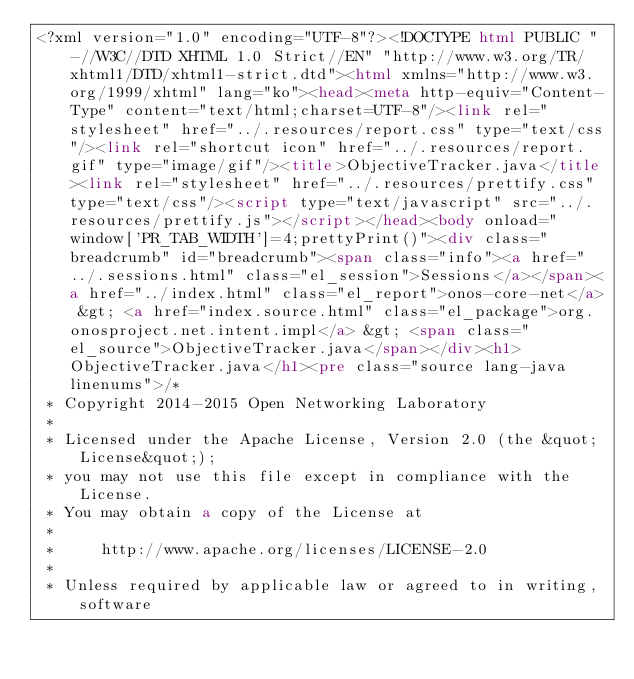<code> <loc_0><loc_0><loc_500><loc_500><_HTML_><?xml version="1.0" encoding="UTF-8"?><!DOCTYPE html PUBLIC "-//W3C//DTD XHTML 1.0 Strict//EN" "http://www.w3.org/TR/xhtml1/DTD/xhtml1-strict.dtd"><html xmlns="http://www.w3.org/1999/xhtml" lang="ko"><head><meta http-equiv="Content-Type" content="text/html;charset=UTF-8"/><link rel="stylesheet" href="../.resources/report.css" type="text/css"/><link rel="shortcut icon" href="../.resources/report.gif" type="image/gif"/><title>ObjectiveTracker.java</title><link rel="stylesheet" href="../.resources/prettify.css" type="text/css"/><script type="text/javascript" src="../.resources/prettify.js"></script></head><body onload="window['PR_TAB_WIDTH']=4;prettyPrint()"><div class="breadcrumb" id="breadcrumb"><span class="info"><a href="../.sessions.html" class="el_session">Sessions</a></span><a href="../index.html" class="el_report">onos-core-net</a> &gt; <a href="index.source.html" class="el_package">org.onosproject.net.intent.impl</a> &gt; <span class="el_source">ObjectiveTracker.java</span></div><h1>ObjectiveTracker.java</h1><pre class="source lang-java linenums">/*
 * Copyright 2014-2015 Open Networking Laboratory
 *
 * Licensed under the Apache License, Version 2.0 (the &quot;License&quot;);
 * you may not use this file except in compliance with the License.
 * You may obtain a copy of the License at
 *
 *     http://www.apache.org/licenses/LICENSE-2.0
 *
 * Unless required by applicable law or agreed to in writing, software</code> 